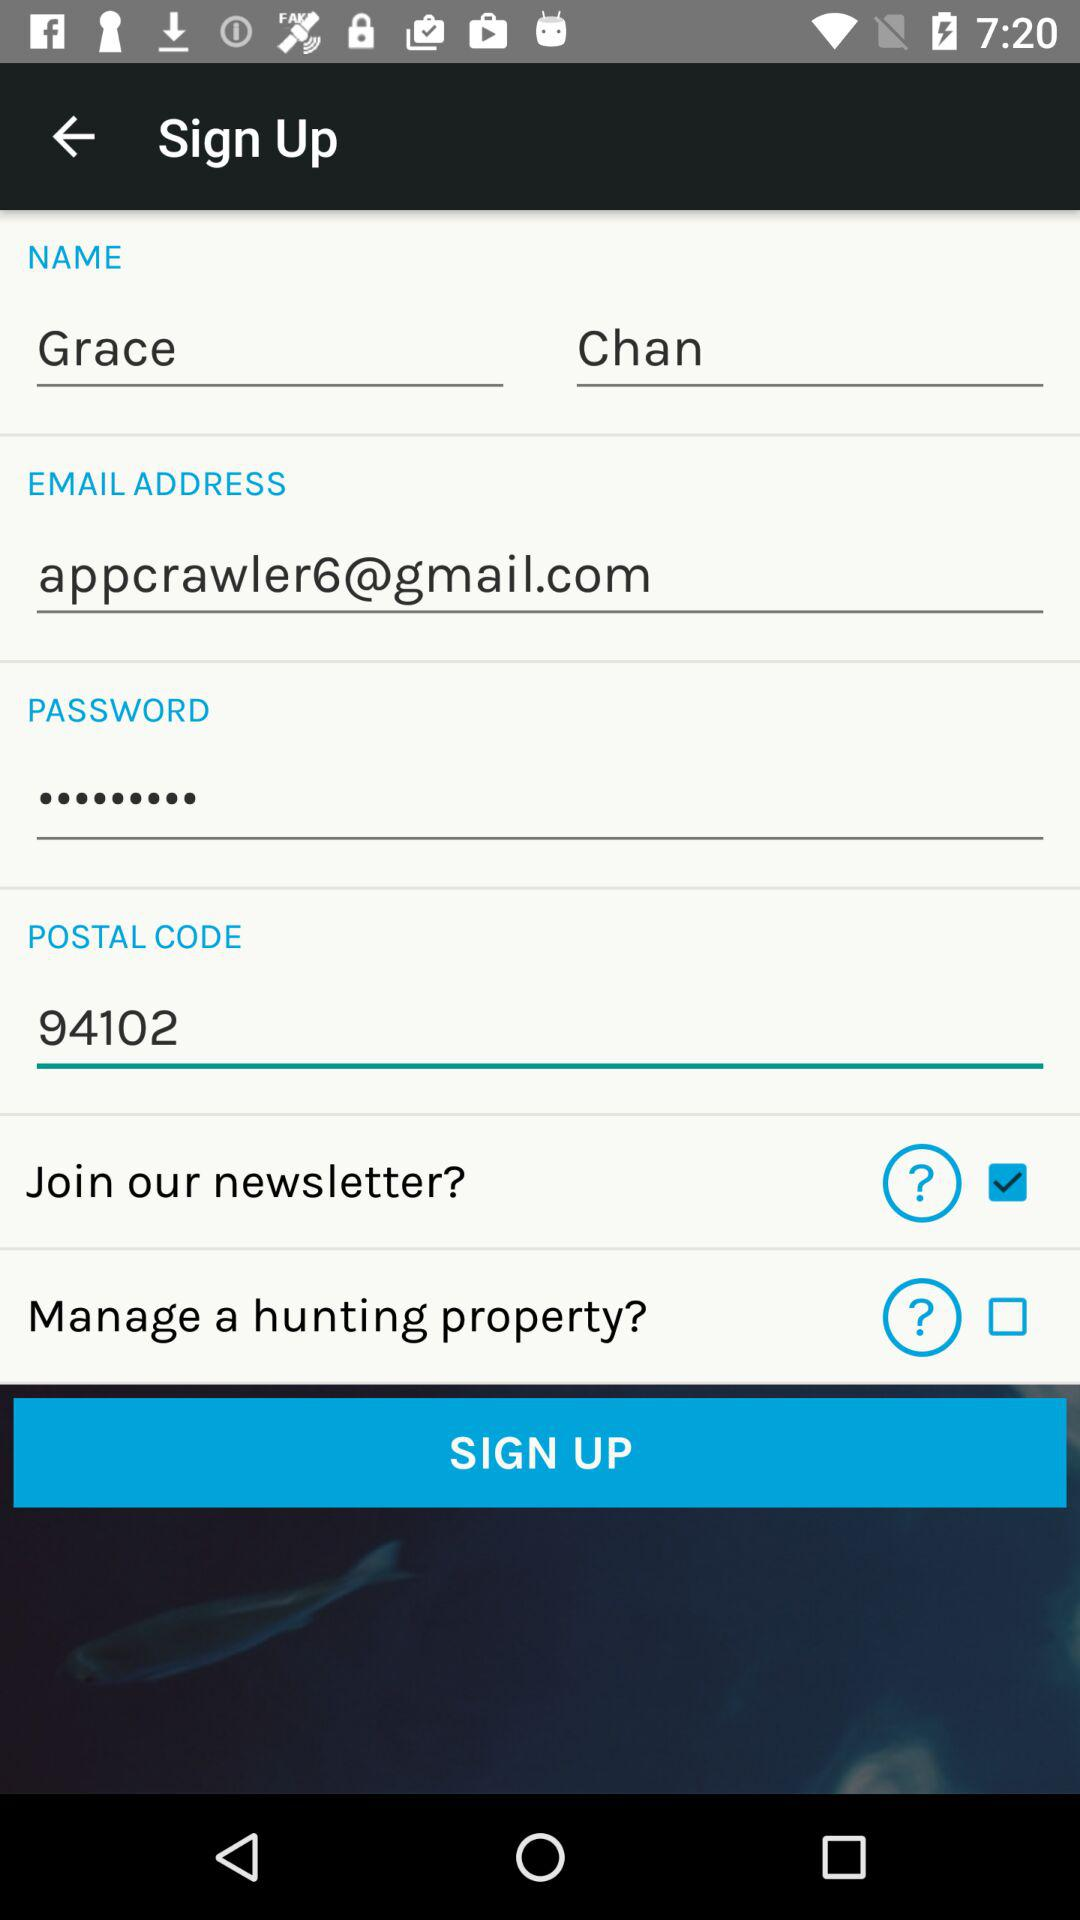What is the status of the "Join our newsletter?"? The status is "on". 